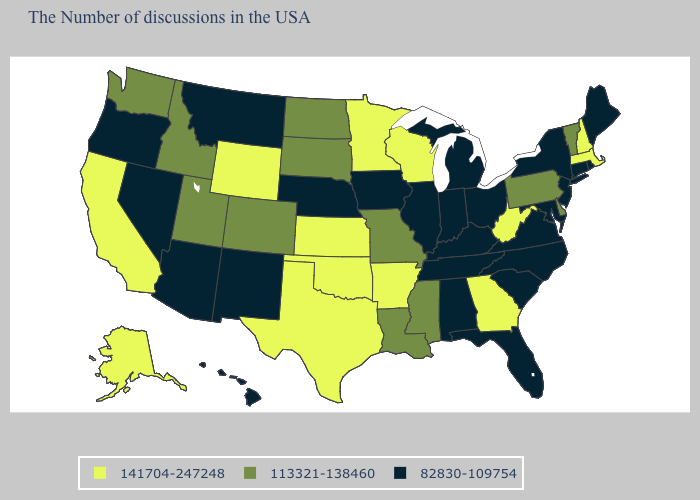Name the states that have a value in the range 141704-247248?
Keep it brief. Massachusetts, New Hampshire, West Virginia, Georgia, Wisconsin, Arkansas, Minnesota, Kansas, Oklahoma, Texas, Wyoming, California, Alaska. Does Massachusetts have the highest value in the Northeast?
Be succinct. Yes. What is the value of North Dakota?
Short answer required. 113321-138460. What is the lowest value in the USA?
Be succinct. 82830-109754. What is the value of Illinois?
Give a very brief answer. 82830-109754. Is the legend a continuous bar?
Give a very brief answer. No. Which states have the lowest value in the USA?
Quick response, please. Maine, Rhode Island, Connecticut, New York, New Jersey, Maryland, Virginia, North Carolina, South Carolina, Ohio, Florida, Michigan, Kentucky, Indiana, Alabama, Tennessee, Illinois, Iowa, Nebraska, New Mexico, Montana, Arizona, Nevada, Oregon, Hawaii. What is the value of Florida?
Answer briefly. 82830-109754. Does Texas have the lowest value in the South?
Keep it brief. No. What is the value of Louisiana?
Keep it brief. 113321-138460. Does Alaska have the highest value in the West?
Quick response, please. Yes. How many symbols are there in the legend?
Concise answer only. 3. What is the value of Minnesota?
Quick response, please. 141704-247248. Name the states that have a value in the range 141704-247248?
Answer briefly. Massachusetts, New Hampshire, West Virginia, Georgia, Wisconsin, Arkansas, Minnesota, Kansas, Oklahoma, Texas, Wyoming, California, Alaska. Does the map have missing data?
Keep it brief. No. 